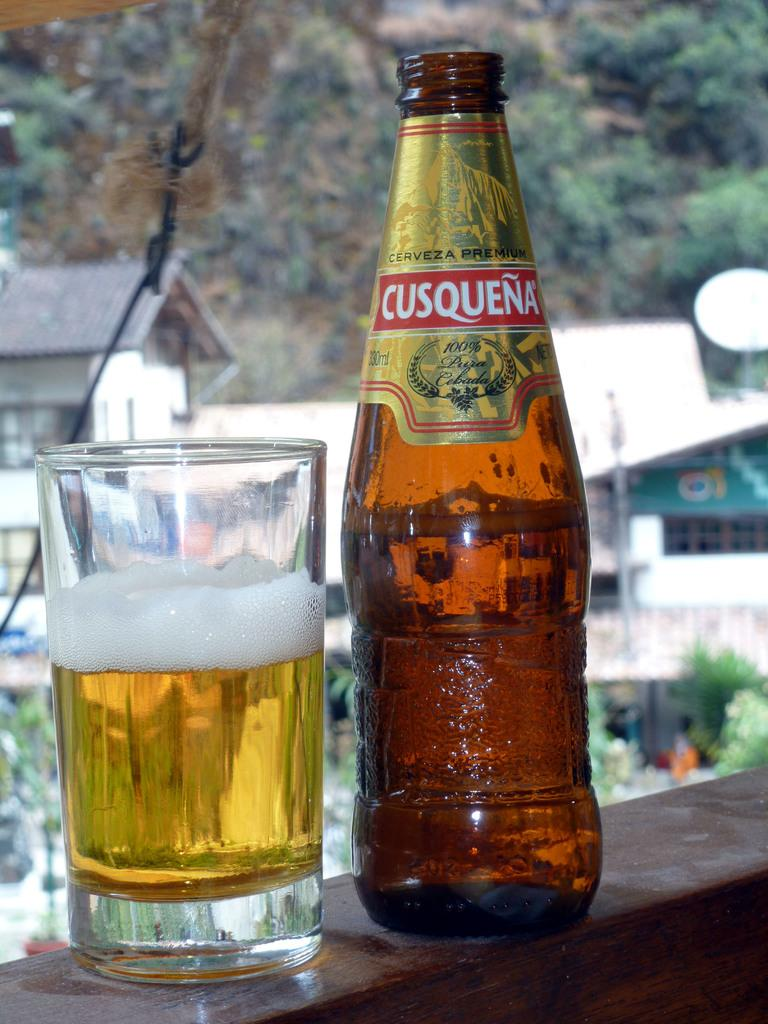Provide a one-sentence caption for the provided image. A cool bottle of Cusquena sits beside a glass half poured. 